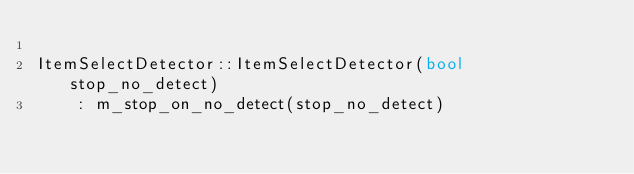<code> <loc_0><loc_0><loc_500><loc_500><_C++_>
ItemSelectDetector::ItemSelectDetector(bool stop_no_detect)
    : m_stop_on_no_detect(stop_no_detect)</code> 